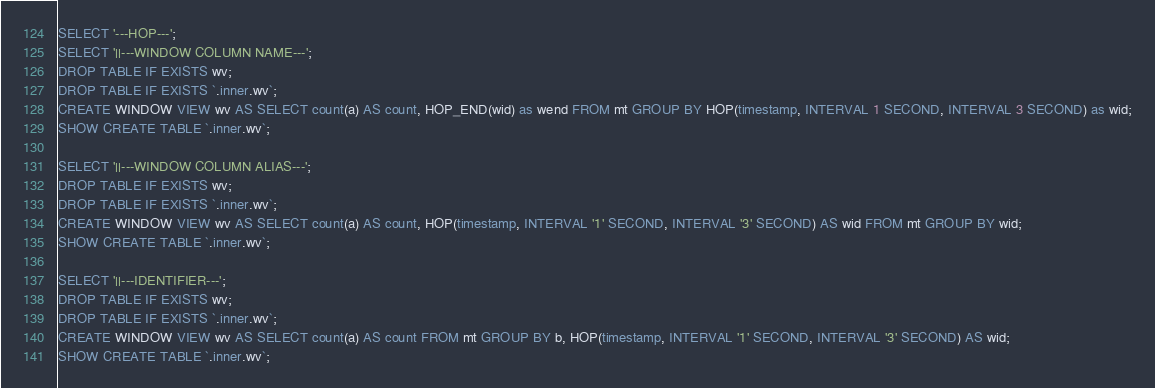<code> <loc_0><loc_0><loc_500><loc_500><_SQL_>

SELECT '---HOP---';
SELECT '||---WINDOW COLUMN NAME---';
DROP TABLE IF EXISTS wv;
DROP TABLE IF EXISTS `.inner.wv`;
CREATE WINDOW VIEW wv AS SELECT count(a) AS count, HOP_END(wid) as wend FROM mt GROUP BY HOP(timestamp, INTERVAL 1 SECOND, INTERVAL 3 SECOND) as wid;
SHOW CREATE TABLE `.inner.wv`;

SELECT '||---WINDOW COLUMN ALIAS---';
DROP TABLE IF EXISTS wv;
DROP TABLE IF EXISTS `.inner.wv`;
CREATE WINDOW VIEW wv AS SELECT count(a) AS count, HOP(timestamp, INTERVAL '1' SECOND, INTERVAL '3' SECOND) AS wid FROM mt GROUP BY wid;
SHOW CREATE TABLE `.inner.wv`;

SELECT '||---IDENTIFIER---';
DROP TABLE IF EXISTS wv;
DROP TABLE IF EXISTS `.inner.wv`;
CREATE WINDOW VIEW wv AS SELECT count(a) AS count FROM mt GROUP BY b, HOP(timestamp, INTERVAL '1' SECOND, INTERVAL '3' SECOND) AS wid;
SHOW CREATE TABLE `.inner.wv`;
</code> 